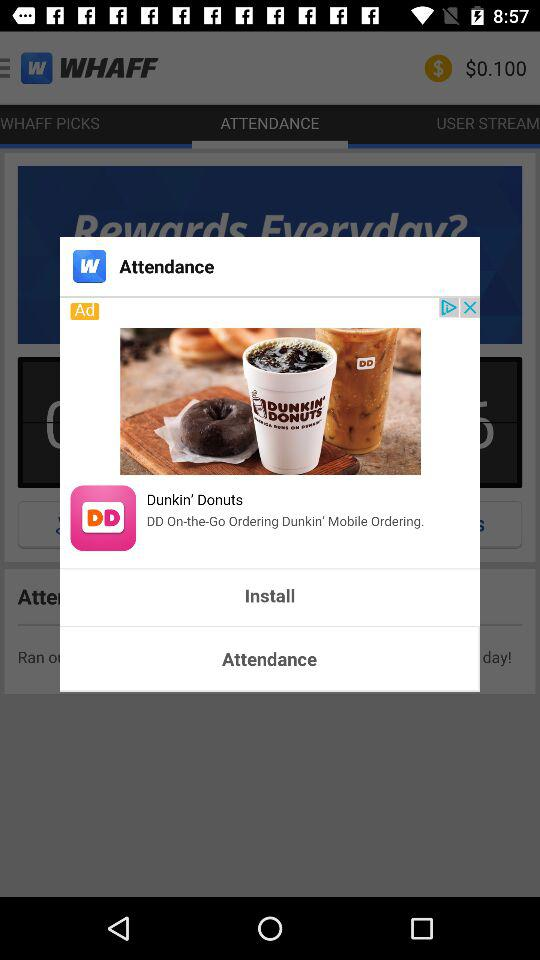What is the price? The price is $0.100. 